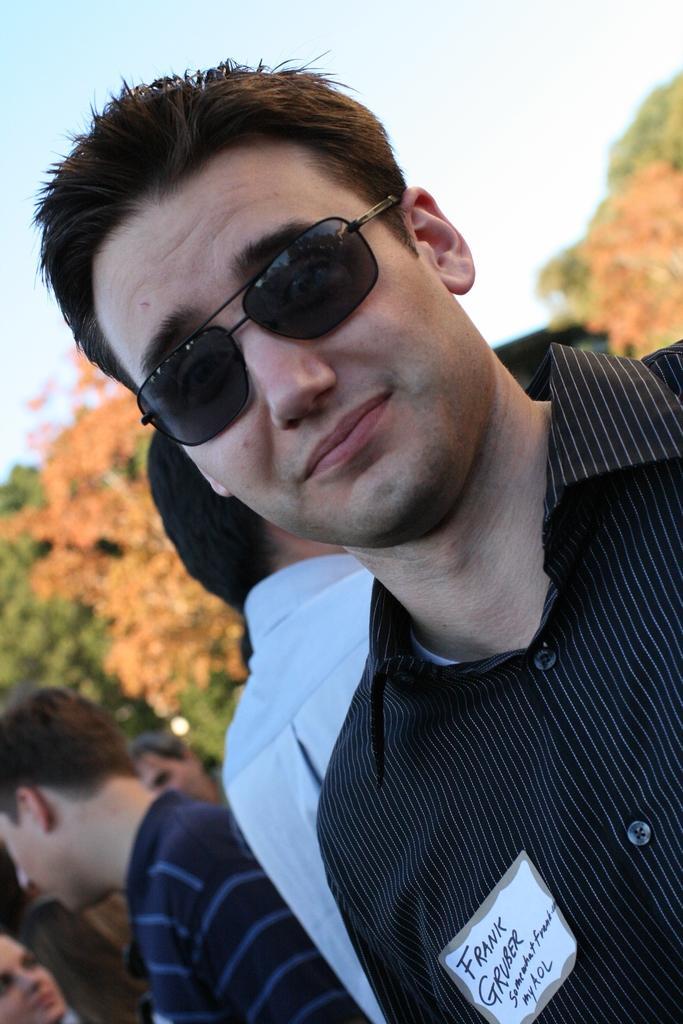Can you describe this image briefly? In this picture I can observe a man wearing spectacles. Behind him I can observe some people. In the background there are trees and sky. 